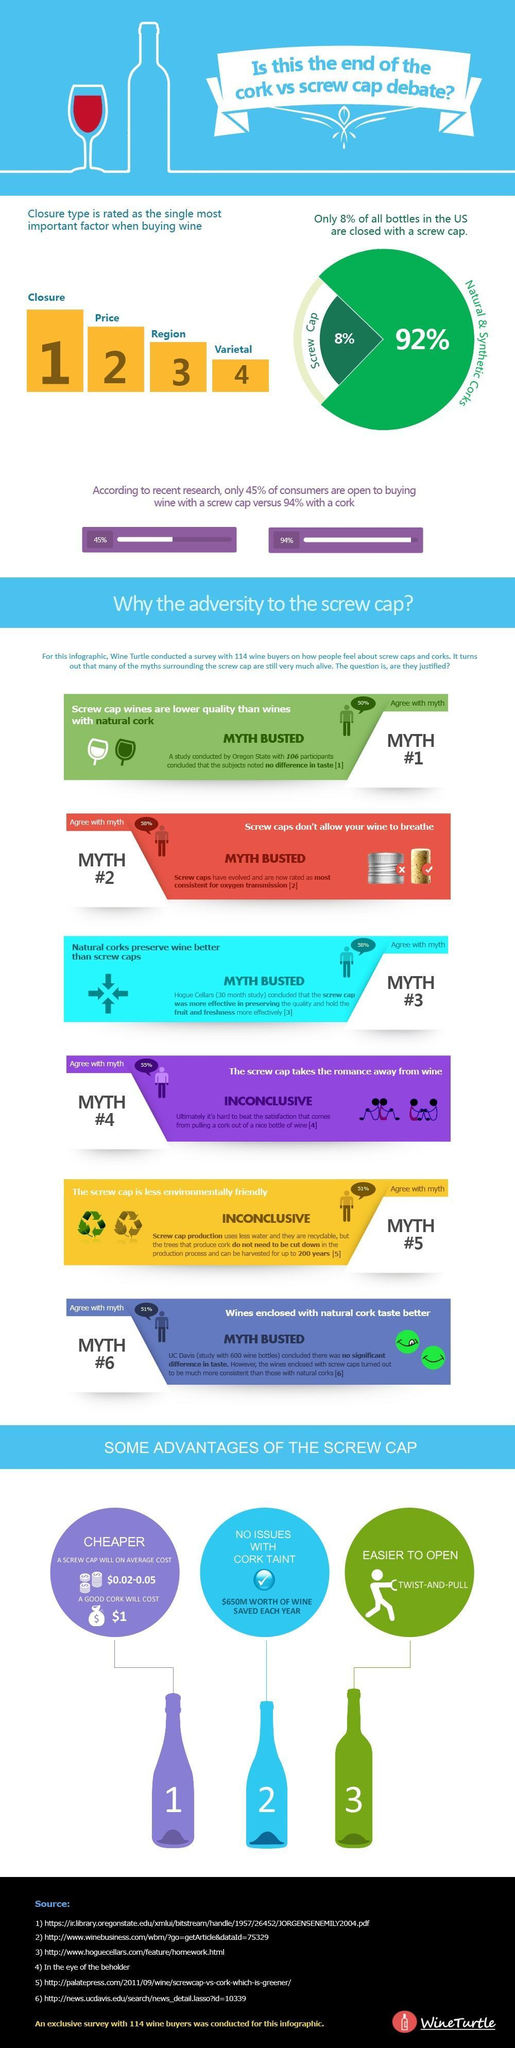How many people agree with myth#1?
Answer the question with a short phrase. 57 people Which is the second most important factor when buying wine in the US? price What percentage of people do not agree with Myth#2? 42 